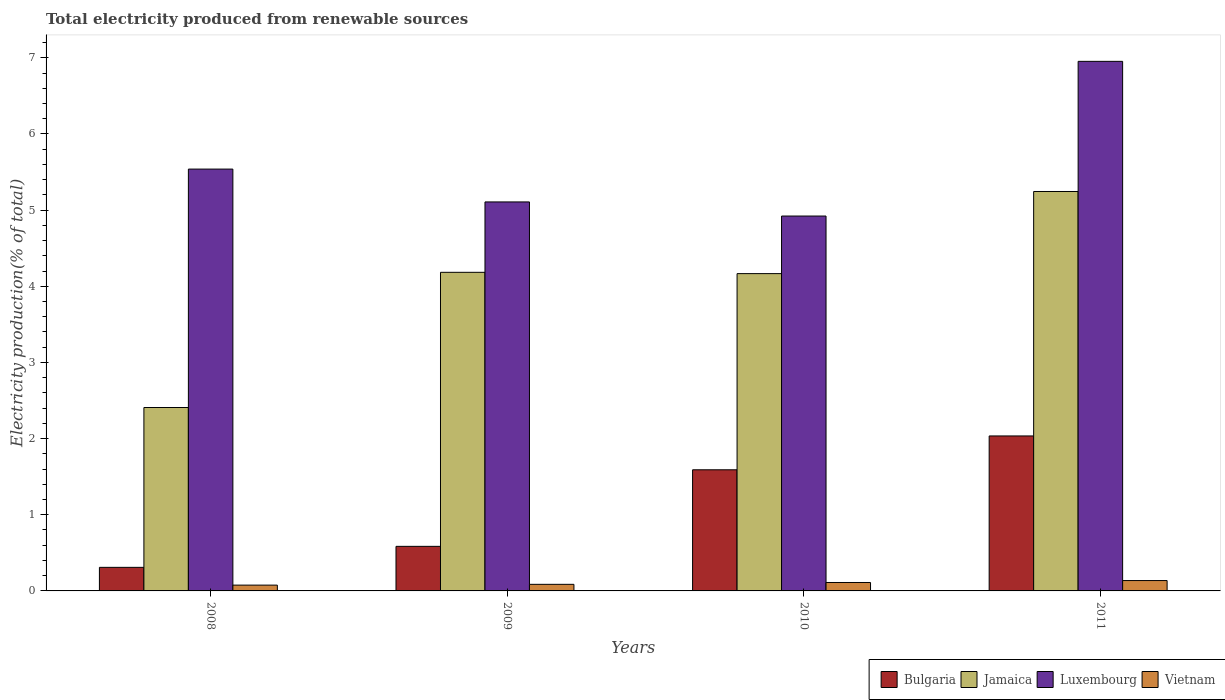How many groups of bars are there?
Offer a very short reply. 4. Are the number of bars on each tick of the X-axis equal?
Make the answer very short. Yes. How many bars are there on the 2nd tick from the left?
Your response must be concise. 4. How many bars are there on the 1st tick from the right?
Provide a succinct answer. 4. What is the total electricity produced in Jamaica in 2008?
Offer a very short reply. 2.41. Across all years, what is the maximum total electricity produced in Jamaica?
Your response must be concise. 5.25. Across all years, what is the minimum total electricity produced in Jamaica?
Keep it short and to the point. 2.41. In which year was the total electricity produced in Bulgaria maximum?
Your answer should be compact. 2011. What is the total total electricity produced in Luxembourg in the graph?
Provide a succinct answer. 22.52. What is the difference between the total electricity produced in Jamaica in 2009 and that in 2010?
Ensure brevity in your answer.  0.02. What is the difference between the total electricity produced in Bulgaria in 2010 and the total electricity produced in Jamaica in 2009?
Offer a very short reply. -2.59. What is the average total electricity produced in Luxembourg per year?
Make the answer very short. 5.63. In the year 2008, what is the difference between the total electricity produced in Luxembourg and total electricity produced in Bulgaria?
Your response must be concise. 5.23. What is the ratio of the total electricity produced in Jamaica in 2008 to that in 2011?
Provide a succinct answer. 0.46. What is the difference between the highest and the second highest total electricity produced in Bulgaria?
Offer a terse response. 0.44. What is the difference between the highest and the lowest total electricity produced in Luxembourg?
Your answer should be compact. 2.03. What does the 2nd bar from the left in 2008 represents?
Your answer should be compact. Jamaica. What does the 3rd bar from the right in 2011 represents?
Provide a succinct answer. Jamaica. Is it the case that in every year, the sum of the total electricity produced in Jamaica and total electricity produced in Luxembourg is greater than the total electricity produced in Vietnam?
Offer a terse response. Yes. How many bars are there?
Your answer should be very brief. 16. Are all the bars in the graph horizontal?
Provide a succinct answer. No. How many years are there in the graph?
Your answer should be compact. 4. Are the values on the major ticks of Y-axis written in scientific E-notation?
Keep it short and to the point. No. Does the graph contain grids?
Provide a short and direct response. No. How many legend labels are there?
Your response must be concise. 4. What is the title of the graph?
Your response must be concise. Total electricity produced from renewable sources. What is the label or title of the X-axis?
Ensure brevity in your answer.  Years. What is the Electricity production(% of total) in Bulgaria in 2008?
Your answer should be very brief. 0.31. What is the Electricity production(% of total) of Jamaica in 2008?
Keep it short and to the point. 2.41. What is the Electricity production(% of total) of Luxembourg in 2008?
Your answer should be compact. 5.54. What is the Electricity production(% of total) of Vietnam in 2008?
Offer a very short reply. 0.08. What is the Electricity production(% of total) in Bulgaria in 2009?
Provide a short and direct response. 0.59. What is the Electricity production(% of total) of Jamaica in 2009?
Provide a succinct answer. 4.18. What is the Electricity production(% of total) of Luxembourg in 2009?
Ensure brevity in your answer.  5.11. What is the Electricity production(% of total) in Vietnam in 2009?
Provide a succinct answer. 0.09. What is the Electricity production(% of total) of Bulgaria in 2010?
Provide a short and direct response. 1.59. What is the Electricity production(% of total) in Jamaica in 2010?
Your response must be concise. 4.17. What is the Electricity production(% of total) of Luxembourg in 2010?
Provide a short and direct response. 4.92. What is the Electricity production(% of total) of Vietnam in 2010?
Ensure brevity in your answer.  0.11. What is the Electricity production(% of total) of Bulgaria in 2011?
Your answer should be very brief. 2.04. What is the Electricity production(% of total) of Jamaica in 2011?
Ensure brevity in your answer.  5.25. What is the Electricity production(% of total) of Luxembourg in 2011?
Keep it short and to the point. 6.95. What is the Electricity production(% of total) of Vietnam in 2011?
Give a very brief answer. 0.14. Across all years, what is the maximum Electricity production(% of total) of Bulgaria?
Offer a very short reply. 2.04. Across all years, what is the maximum Electricity production(% of total) of Jamaica?
Offer a terse response. 5.25. Across all years, what is the maximum Electricity production(% of total) in Luxembourg?
Your response must be concise. 6.95. Across all years, what is the maximum Electricity production(% of total) in Vietnam?
Your response must be concise. 0.14. Across all years, what is the minimum Electricity production(% of total) of Bulgaria?
Give a very brief answer. 0.31. Across all years, what is the minimum Electricity production(% of total) in Jamaica?
Offer a very short reply. 2.41. Across all years, what is the minimum Electricity production(% of total) in Luxembourg?
Offer a very short reply. 4.92. Across all years, what is the minimum Electricity production(% of total) in Vietnam?
Provide a succinct answer. 0.08. What is the total Electricity production(% of total) of Bulgaria in the graph?
Give a very brief answer. 4.52. What is the total Electricity production(% of total) of Jamaica in the graph?
Ensure brevity in your answer.  16. What is the total Electricity production(% of total) of Luxembourg in the graph?
Provide a short and direct response. 22.52. What is the total Electricity production(% of total) of Vietnam in the graph?
Your response must be concise. 0.41. What is the difference between the Electricity production(% of total) of Bulgaria in 2008 and that in 2009?
Provide a succinct answer. -0.28. What is the difference between the Electricity production(% of total) in Jamaica in 2008 and that in 2009?
Your answer should be compact. -1.78. What is the difference between the Electricity production(% of total) in Luxembourg in 2008 and that in 2009?
Your answer should be very brief. 0.43. What is the difference between the Electricity production(% of total) of Vietnam in 2008 and that in 2009?
Keep it short and to the point. -0.01. What is the difference between the Electricity production(% of total) of Bulgaria in 2008 and that in 2010?
Offer a very short reply. -1.28. What is the difference between the Electricity production(% of total) in Jamaica in 2008 and that in 2010?
Your answer should be compact. -1.76. What is the difference between the Electricity production(% of total) of Luxembourg in 2008 and that in 2010?
Your answer should be compact. 0.62. What is the difference between the Electricity production(% of total) in Vietnam in 2008 and that in 2010?
Your answer should be very brief. -0.03. What is the difference between the Electricity production(% of total) of Bulgaria in 2008 and that in 2011?
Keep it short and to the point. -1.73. What is the difference between the Electricity production(% of total) in Jamaica in 2008 and that in 2011?
Make the answer very short. -2.84. What is the difference between the Electricity production(% of total) of Luxembourg in 2008 and that in 2011?
Ensure brevity in your answer.  -1.41. What is the difference between the Electricity production(% of total) in Vietnam in 2008 and that in 2011?
Your answer should be compact. -0.06. What is the difference between the Electricity production(% of total) in Bulgaria in 2009 and that in 2010?
Keep it short and to the point. -1.01. What is the difference between the Electricity production(% of total) in Jamaica in 2009 and that in 2010?
Offer a terse response. 0.02. What is the difference between the Electricity production(% of total) in Luxembourg in 2009 and that in 2010?
Offer a terse response. 0.19. What is the difference between the Electricity production(% of total) in Vietnam in 2009 and that in 2010?
Provide a succinct answer. -0.02. What is the difference between the Electricity production(% of total) of Bulgaria in 2009 and that in 2011?
Provide a short and direct response. -1.45. What is the difference between the Electricity production(% of total) in Jamaica in 2009 and that in 2011?
Offer a very short reply. -1.06. What is the difference between the Electricity production(% of total) of Luxembourg in 2009 and that in 2011?
Make the answer very short. -1.85. What is the difference between the Electricity production(% of total) of Vietnam in 2009 and that in 2011?
Your response must be concise. -0.05. What is the difference between the Electricity production(% of total) of Bulgaria in 2010 and that in 2011?
Keep it short and to the point. -0.44. What is the difference between the Electricity production(% of total) of Jamaica in 2010 and that in 2011?
Give a very brief answer. -1.08. What is the difference between the Electricity production(% of total) in Luxembourg in 2010 and that in 2011?
Make the answer very short. -2.03. What is the difference between the Electricity production(% of total) in Vietnam in 2010 and that in 2011?
Your answer should be very brief. -0.03. What is the difference between the Electricity production(% of total) in Bulgaria in 2008 and the Electricity production(% of total) in Jamaica in 2009?
Your answer should be very brief. -3.87. What is the difference between the Electricity production(% of total) of Bulgaria in 2008 and the Electricity production(% of total) of Luxembourg in 2009?
Give a very brief answer. -4.8. What is the difference between the Electricity production(% of total) in Bulgaria in 2008 and the Electricity production(% of total) in Vietnam in 2009?
Offer a terse response. 0.22. What is the difference between the Electricity production(% of total) in Jamaica in 2008 and the Electricity production(% of total) in Luxembourg in 2009?
Your response must be concise. -2.7. What is the difference between the Electricity production(% of total) of Jamaica in 2008 and the Electricity production(% of total) of Vietnam in 2009?
Make the answer very short. 2.32. What is the difference between the Electricity production(% of total) of Luxembourg in 2008 and the Electricity production(% of total) of Vietnam in 2009?
Ensure brevity in your answer.  5.45. What is the difference between the Electricity production(% of total) of Bulgaria in 2008 and the Electricity production(% of total) of Jamaica in 2010?
Your response must be concise. -3.86. What is the difference between the Electricity production(% of total) of Bulgaria in 2008 and the Electricity production(% of total) of Luxembourg in 2010?
Make the answer very short. -4.61. What is the difference between the Electricity production(% of total) of Bulgaria in 2008 and the Electricity production(% of total) of Vietnam in 2010?
Provide a succinct answer. 0.2. What is the difference between the Electricity production(% of total) of Jamaica in 2008 and the Electricity production(% of total) of Luxembourg in 2010?
Keep it short and to the point. -2.51. What is the difference between the Electricity production(% of total) in Jamaica in 2008 and the Electricity production(% of total) in Vietnam in 2010?
Make the answer very short. 2.3. What is the difference between the Electricity production(% of total) in Luxembourg in 2008 and the Electricity production(% of total) in Vietnam in 2010?
Provide a succinct answer. 5.43. What is the difference between the Electricity production(% of total) in Bulgaria in 2008 and the Electricity production(% of total) in Jamaica in 2011?
Your response must be concise. -4.94. What is the difference between the Electricity production(% of total) of Bulgaria in 2008 and the Electricity production(% of total) of Luxembourg in 2011?
Offer a terse response. -6.64. What is the difference between the Electricity production(% of total) of Bulgaria in 2008 and the Electricity production(% of total) of Vietnam in 2011?
Provide a short and direct response. 0.17. What is the difference between the Electricity production(% of total) of Jamaica in 2008 and the Electricity production(% of total) of Luxembourg in 2011?
Your answer should be compact. -4.55. What is the difference between the Electricity production(% of total) in Jamaica in 2008 and the Electricity production(% of total) in Vietnam in 2011?
Provide a short and direct response. 2.27. What is the difference between the Electricity production(% of total) of Luxembourg in 2008 and the Electricity production(% of total) of Vietnam in 2011?
Your answer should be very brief. 5.4. What is the difference between the Electricity production(% of total) in Bulgaria in 2009 and the Electricity production(% of total) in Jamaica in 2010?
Provide a short and direct response. -3.58. What is the difference between the Electricity production(% of total) in Bulgaria in 2009 and the Electricity production(% of total) in Luxembourg in 2010?
Offer a very short reply. -4.34. What is the difference between the Electricity production(% of total) of Bulgaria in 2009 and the Electricity production(% of total) of Vietnam in 2010?
Offer a very short reply. 0.47. What is the difference between the Electricity production(% of total) of Jamaica in 2009 and the Electricity production(% of total) of Luxembourg in 2010?
Ensure brevity in your answer.  -0.74. What is the difference between the Electricity production(% of total) in Jamaica in 2009 and the Electricity production(% of total) in Vietnam in 2010?
Your response must be concise. 4.07. What is the difference between the Electricity production(% of total) in Luxembourg in 2009 and the Electricity production(% of total) in Vietnam in 2010?
Give a very brief answer. 5. What is the difference between the Electricity production(% of total) in Bulgaria in 2009 and the Electricity production(% of total) in Jamaica in 2011?
Offer a very short reply. -4.66. What is the difference between the Electricity production(% of total) in Bulgaria in 2009 and the Electricity production(% of total) in Luxembourg in 2011?
Provide a short and direct response. -6.37. What is the difference between the Electricity production(% of total) of Bulgaria in 2009 and the Electricity production(% of total) of Vietnam in 2011?
Keep it short and to the point. 0.45. What is the difference between the Electricity production(% of total) of Jamaica in 2009 and the Electricity production(% of total) of Luxembourg in 2011?
Your answer should be compact. -2.77. What is the difference between the Electricity production(% of total) in Jamaica in 2009 and the Electricity production(% of total) in Vietnam in 2011?
Your response must be concise. 4.05. What is the difference between the Electricity production(% of total) of Luxembourg in 2009 and the Electricity production(% of total) of Vietnam in 2011?
Your answer should be compact. 4.97. What is the difference between the Electricity production(% of total) of Bulgaria in 2010 and the Electricity production(% of total) of Jamaica in 2011?
Offer a terse response. -3.65. What is the difference between the Electricity production(% of total) of Bulgaria in 2010 and the Electricity production(% of total) of Luxembourg in 2011?
Offer a very short reply. -5.36. What is the difference between the Electricity production(% of total) of Bulgaria in 2010 and the Electricity production(% of total) of Vietnam in 2011?
Your answer should be very brief. 1.45. What is the difference between the Electricity production(% of total) in Jamaica in 2010 and the Electricity production(% of total) in Luxembourg in 2011?
Your answer should be compact. -2.79. What is the difference between the Electricity production(% of total) in Jamaica in 2010 and the Electricity production(% of total) in Vietnam in 2011?
Give a very brief answer. 4.03. What is the difference between the Electricity production(% of total) of Luxembourg in 2010 and the Electricity production(% of total) of Vietnam in 2011?
Keep it short and to the point. 4.79. What is the average Electricity production(% of total) of Bulgaria per year?
Your answer should be compact. 1.13. What is the average Electricity production(% of total) of Jamaica per year?
Provide a succinct answer. 4. What is the average Electricity production(% of total) of Luxembourg per year?
Your answer should be very brief. 5.63. What is the average Electricity production(% of total) in Vietnam per year?
Make the answer very short. 0.1. In the year 2008, what is the difference between the Electricity production(% of total) of Bulgaria and Electricity production(% of total) of Jamaica?
Keep it short and to the point. -2.1. In the year 2008, what is the difference between the Electricity production(% of total) of Bulgaria and Electricity production(% of total) of Luxembourg?
Provide a short and direct response. -5.23. In the year 2008, what is the difference between the Electricity production(% of total) of Bulgaria and Electricity production(% of total) of Vietnam?
Give a very brief answer. 0.23. In the year 2008, what is the difference between the Electricity production(% of total) in Jamaica and Electricity production(% of total) in Luxembourg?
Provide a succinct answer. -3.13. In the year 2008, what is the difference between the Electricity production(% of total) in Jamaica and Electricity production(% of total) in Vietnam?
Offer a very short reply. 2.33. In the year 2008, what is the difference between the Electricity production(% of total) in Luxembourg and Electricity production(% of total) in Vietnam?
Offer a terse response. 5.46. In the year 2009, what is the difference between the Electricity production(% of total) in Bulgaria and Electricity production(% of total) in Jamaica?
Ensure brevity in your answer.  -3.6. In the year 2009, what is the difference between the Electricity production(% of total) of Bulgaria and Electricity production(% of total) of Luxembourg?
Provide a succinct answer. -4.52. In the year 2009, what is the difference between the Electricity production(% of total) in Bulgaria and Electricity production(% of total) in Vietnam?
Offer a very short reply. 0.5. In the year 2009, what is the difference between the Electricity production(% of total) of Jamaica and Electricity production(% of total) of Luxembourg?
Your answer should be very brief. -0.92. In the year 2009, what is the difference between the Electricity production(% of total) in Jamaica and Electricity production(% of total) in Vietnam?
Provide a short and direct response. 4.1. In the year 2009, what is the difference between the Electricity production(% of total) in Luxembourg and Electricity production(% of total) in Vietnam?
Your response must be concise. 5.02. In the year 2010, what is the difference between the Electricity production(% of total) in Bulgaria and Electricity production(% of total) in Jamaica?
Provide a short and direct response. -2.58. In the year 2010, what is the difference between the Electricity production(% of total) in Bulgaria and Electricity production(% of total) in Luxembourg?
Provide a succinct answer. -3.33. In the year 2010, what is the difference between the Electricity production(% of total) of Bulgaria and Electricity production(% of total) of Vietnam?
Provide a succinct answer. 1.48. In the year 2010, what is the difference between the Electricity production(% of total) in Jamaica and Electricity production(% of total) in Luxembourg?
Offer a very short reply. -0.76. In the year 2010, what is the difference between the Electricity production(% of total) in Jamaica and Electricity production(% of total) in Vietnam?
Provide a short and direct response. 4.06. In the year 2010, what is the difference between the Electricity production(% of total) of Luxembourg and Electricity production(% of total) of Vietnam?
Your answer should be very brief. 4.81. In the year 2011, what is the difference between the Electricity production(% of total) in Bulgaria and Electricity production(% of total) in Jamaica?
Make the answer very short. -3.21. In the year 2011, what is the difference between the Electricity production(% of total) of Bulgaria and Electricity production(% of total) of Luxembourg?
Provide a succinct answer. -4.92. In the year 2011, what is the difference between the Electricity production(% of total) in Bulgaria and Electricity production(% of total) in Vietnam?
Give a very brief answer. 1.9. In the year 2011, what is the difference between the Electricity production(% of total) of Jamaica and Electricity production(% of total) of Luxembourg?
Your response must be concise. -1.71. In the year 2011, what is the difference between the Electricity production(% of total) of Jamaica and Electricity production(% of total) of Vietnam?
Offer a very short reply. 5.11. In the year 2011, what is the difference between the Electricity production(% of total) of Luxembourg and Electricity production(% of total) of Vietnam?
Offer a very short reply. 6.82. What is the ratio of the Electricity production(% of total) of Bulgaria in 2008 to that in 2009?
Your answer should be compact. 0.53. What is the ratio of the Electricity production(% of total) of Jamaica in 2008 to that in 2009?
Ensure brevity in your answer.  0.58. What is the ratio of the Electricity production(% of total) of Luxembourg in 2008 to that in 2009?
Your response must be concise. 1.08. What is the ratio of the Electricity production(% of total) in Vietnam in 2008 to that in 2009?
Your answer should be compact. 0.88. What is the ratio of the Electricity production(% of total) in Bulgaria in 2008 to that in 2010?
Provide a succinct answer. 0.19. What is the ratio of the Electricity production(% of total) of Jamaica in 2008 to that in 2010?
Provide a succinct answer. 0.58. What is the ratio of the Electricity production(% of total) of Luxembourg in 2008 to that in 2010?
Offer a terse response. 1.13. What is the ratio of the Electricity production(% of total) in Vietnam in 2008 to that in 2010?
Offer a terse response. 0.69. What is the ratio of the Electricity production(% of total) of Bulgaria in 2008 to that in 2011?
Offer a terse response. 0.15. What is the ratio of the Electricity production(% of total) of Jamaica in 2008 to that in 2011?
Your response must be concise. 0.46. What is the ratio of the Electricity production(% of total) in Luxembourg in 2008 to that in 2011?
Offer a terse response. 0.8. What is the ratio of the Electricity production(% of total) of Vietnam in 2008 to that in 2011?
Give a very brief answer. 0.56. What is the ratio of the Electricity production(% of total) in Bulgaria in 2009 to that in 2010?
Keep it short and to the point. 0.37. What is the ratio of the Electricity production(% of total) of Jamaica in 2009 to that in 2010?
Offer a very short reply. 1. What is the ratio of the Electricity production(% of total) of Luxembourg in 2009 to that in 2010?
Your response must be concise. 1.04. What is the ratio of the Electricity production(% of total) of Vietnam in 2009 to that in 2010?
Your answer should be very brief. 0.78. What is the ratio of the Electricity production(% of total) in Bulgaria in 2009 to that in 2011?
Keep it short and to the point. 0.29. What is the ratio of the Electricity production(% of total) in Jamaica in 2009 to that in 2011?
Provide a short and direct response. 0.8. What is the ratio of the Electricity production(% of total) in Luxembourg in 2009 to that in 2011?
Your answer should be compact. 0.73. What is the ratio of the Electricity production(% of total) in Vietnam in 2009 to that in 2011?
Your response must be concise. 0.64. What is the ratio of the Electricity production(% of total) of Bulgaria in 2010 to that in 2011?
Provide a succinct answer. 0.78. What is the ratio of the Electricity production(% of total) in Jamaica in 2010 to that in 2011?
Ensure brevity in your answer.  0.79. What is the ratio of the Electricity production(% of total) of Luxembourg in 2010 to that in 2011?
Your response must be concise. 0.71. What is the ratio of the Electricity production(% of total) in Vietnam in 2010 to that in 2011?
Ensure brevity in your answer.  0.81. What is the difference between the highest and the second highest Electricity production(% of total) in Bulgaria?
Provide a short and direct response. 0.44. What is the difference between the highest and the second highest Electricity production(% of total) in Jamaica?
Offer a very short reply. 1.06. What is the difference between the highest and the second highest Electricity production(% of total) of Luxembourg?
Your answer should be very brief. 1.41. What is the difference between the highest and the second highest Electricity production(% of total) of Vietnam?
Provide a succinct answer. 0.03. What is the difference between the highest and the lowest Electricity production(% of total) of Bulgaria?
Ensure brevity in your answer.  1.73. What is the difference between the highest and the lowest Electricity production(% of total) of Jamaica?
Your answer should be very brief. 2.84. What is the difference between the highest and the lowest Electricity production(% of total) of Luxembourg?
Provide a short and direct response. 2.03. What is the difference between the highest and the lowest Electricity production(% of total) in Vietnam?
Offer a very short reply. 0.06. 